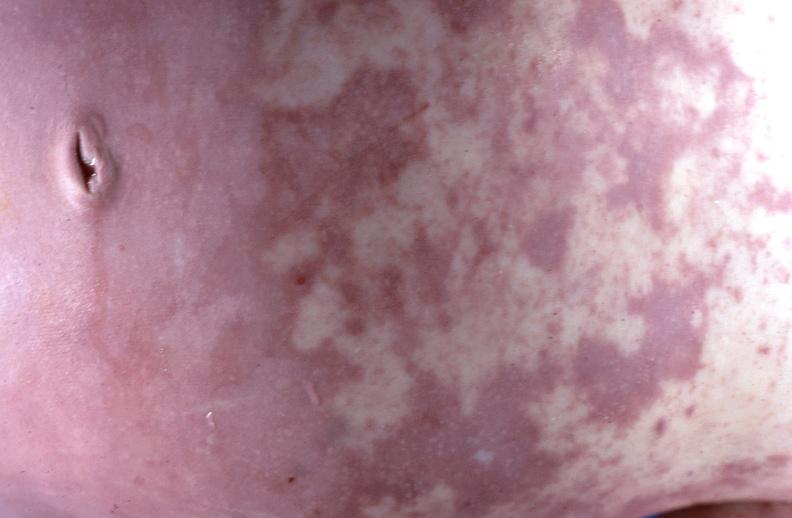why does this image show gram negative septicemia?
Answer the question using a single word or phrase. Due to scalp electrode in a neonate 